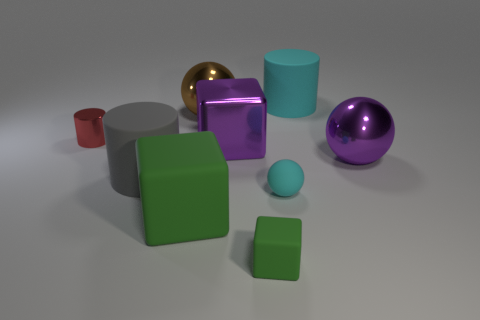Subtract all large shiny spheres. How many spheres are left? 1 Subtract all gray cylinders. How many cylinders are left? 2 Subtract 2 blocks. How many blocks are left? 1 Subtract all purple cylinders. Subtract all cyan balls. How many cylinders are left? 3 Subtract all gray balls. How many red cylinders are left? 1 Subtract all big red metallic spheres. Subtract all large spheres. How many objects are left? 7 Add 1 big cylinders. How many big cylinders are left? 3 Add 9 big brown rubber balls. How many big brown rubber balls exist? 9 Subtract 1 purple blocks. How many objects are left? 8 Subtract all cylinders. How many objects are left? 6 